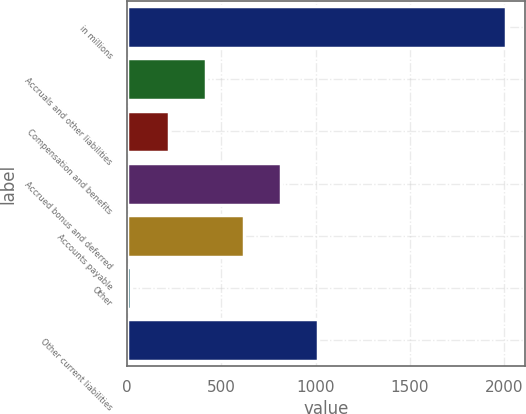<chart> <loc_0><loc_0><loc_500><loc_500><bar_chart><fcel>in millions<fcel>Accruals and other liabilities<fcel>Compensation and benefits<fcel>Accrued bonus and deferred<fcel>Accounts payable<fcel>Other<fcel>Other current liabilities<nl><fcel>2008<fcel>418.8<fcel>220.15<fcel>816.1<fcel>617.45<fcel>21.5<fcel>1014.75<nl></chart> 